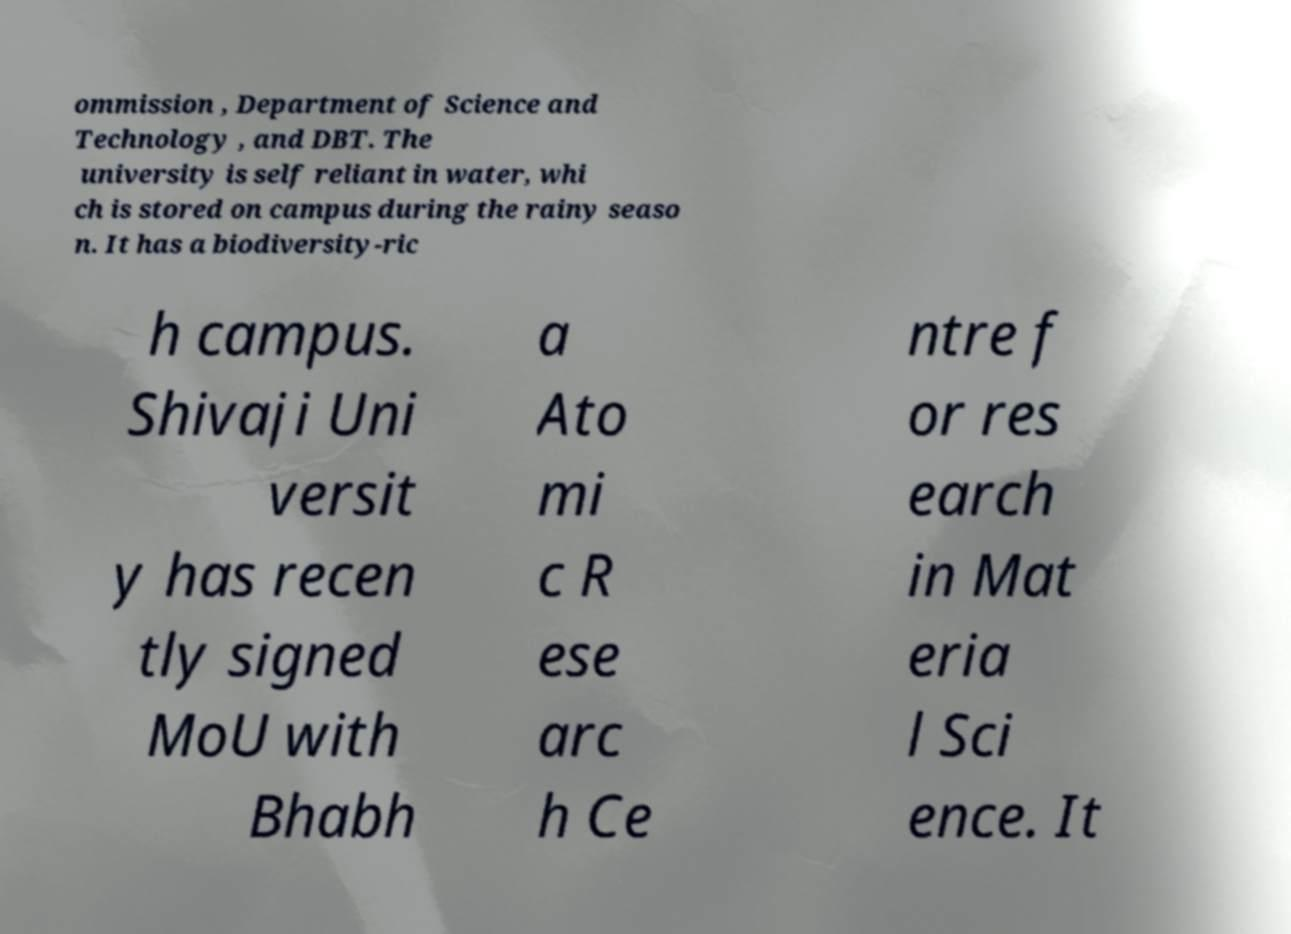I need the written content from this picture converted into text. Can you do that? ommission , Department of Science and Technology , and DBT. The university is self reliant in water, whi ch is stored on campus during the rainy seaso n. It has a biodiversity-ric h campus. Shivaji Uni versit y has recen tly signed MoU with Bhabh a Ato mi c R ese arc h Ce ntre f or res earch in Mat eria l Sci ence. It 